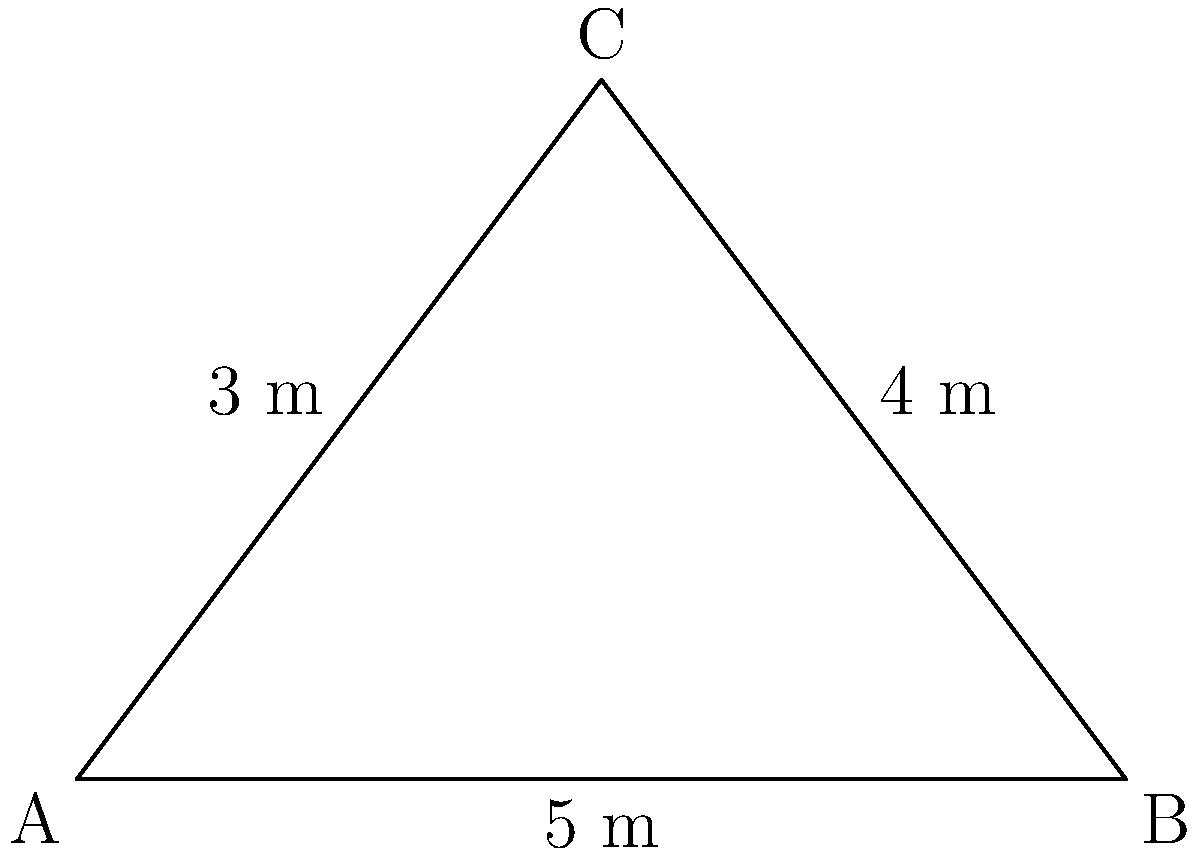You're designing a triangular-shaped listening room for your vinyl collection. The room has side lengths of 3 m, 4 m, and 5 m. What is the area of this room in square meters? To find the area of a triangle when given the lengths of all three sides, we can use Heron's formula:

1) Heron's formula states that the area $A$ of a triangle with sides $a$, $b$, and $c$ is:

   $A = \sqrt{s(s-a)(s-b)(s-c)}$

   where $s$ is the semi-perimeter: $s = \frac{a+b+c}{2}$

2) In this case, $a = 3$ m, $b = 4$ m, and $c = 5$ m

3) Calculate the semi-perimeter:
   $s = \frac{3+4+5}{2} = \frac{12}{2} = 6$ m

4) Now, substitute these values into Heron's formula:

   $A = \sqrt{6(6-3)(6-4)(6-5)}$
   $= \sqrt{6 \cdot 3 \cdot 2 \cdot 1}$
   $= \sqrt{36}$
   $= 6$

5) Therefore, the area of the listening room is 6 square meters.
Answer: 6 m² 